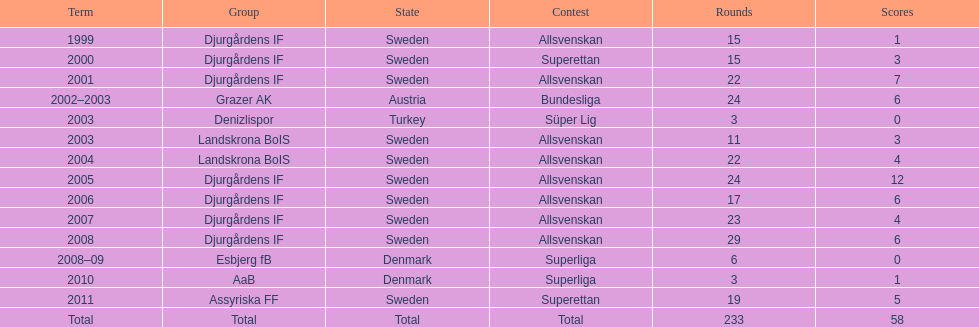What was the number of goals he scored in 2005? 12. 